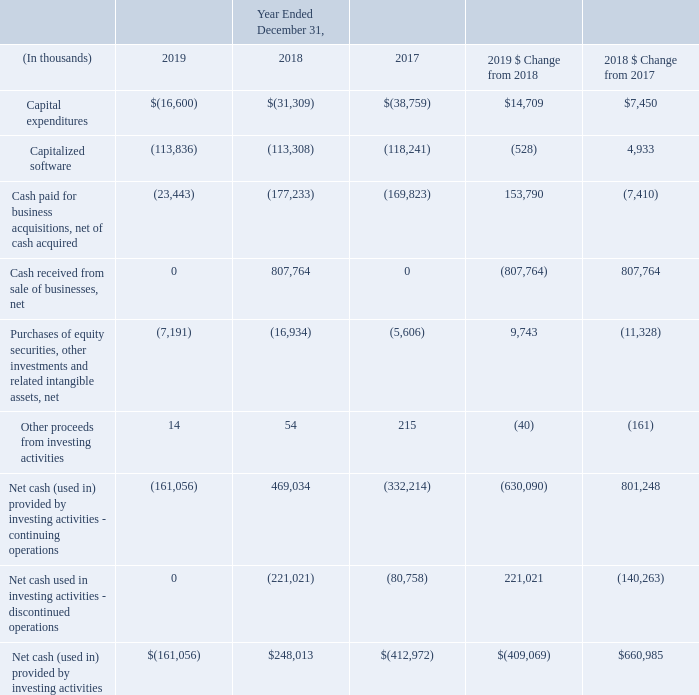Investing Cash Flow Activities
Year Ended December 31, 2019 Compared with the Year Ended December 31, 2018
Net cash used in investing activities – continuing operations during the year ended December 31, 2019 resulted from the absence of the sale of businesses compared to prior year. The sale of Netsmart and OneContent produced significant investing cash inflows during 2018, which was partially offset with cash paid for the acquisitions of Practice Fusion and Health Grid. Capital expenditures also decreased in 2019 compared with prior year.
Year Ended December 31, 2018 Compared with the Year Ended December 31, 2017
We had cash inflows from investing activities – continuing operations during the year ended December 31, 2018 compared with cash outflows from investing activities – continuing operations during the year ended December 31, 2017, which was primarily driven by cash proceeds of $567 million from the sale of our investment in Netsmart and $241 million of net cash proceeds from the divestiture of the OneContent business during 2018.
Cash used in investing activities also included the purchase of Practice Fusion and Health Grid, which were mostly offset by lower overall capital expenditures during 2018.
Net cash used in investing activities – discontinued operations increased during the year ended December 31, 2018 compared with the prior year, primarily due to larger business acquisitions completed by Netsmart during 2018.
What led to Net cash used in investing activities – continuing operations during the year ended December 31, 2019? The absence of the sale of businesses compared to prior year. What was the impact of the sale of Netsmart and OneContent? Produced significant investing cash inflows during 2018, which was partially offset with cash paid for the acquisitions of practice fusion and health grid. How much was the net cash proceeds from the divestiture of the OneContent business during 2018? $241 million. What is the average Capital expenditures, for the year 2019 to 2018?
Answer scale should be: thousand. -(16,600+31,309) / 2
Answer: -23954.5. What is the average Capitalized software, for the year 2019 to 2018?
Answer scale should be: thousand. -(113,836+113,308) / 2
Answer: -113572. What is the average Cash paid for business acquisitions, net of cash acquired, for the year 2019 to 2018?
Answer scale should be: thousand. -(23,443+177,233) / 2
Answer: -100338. 